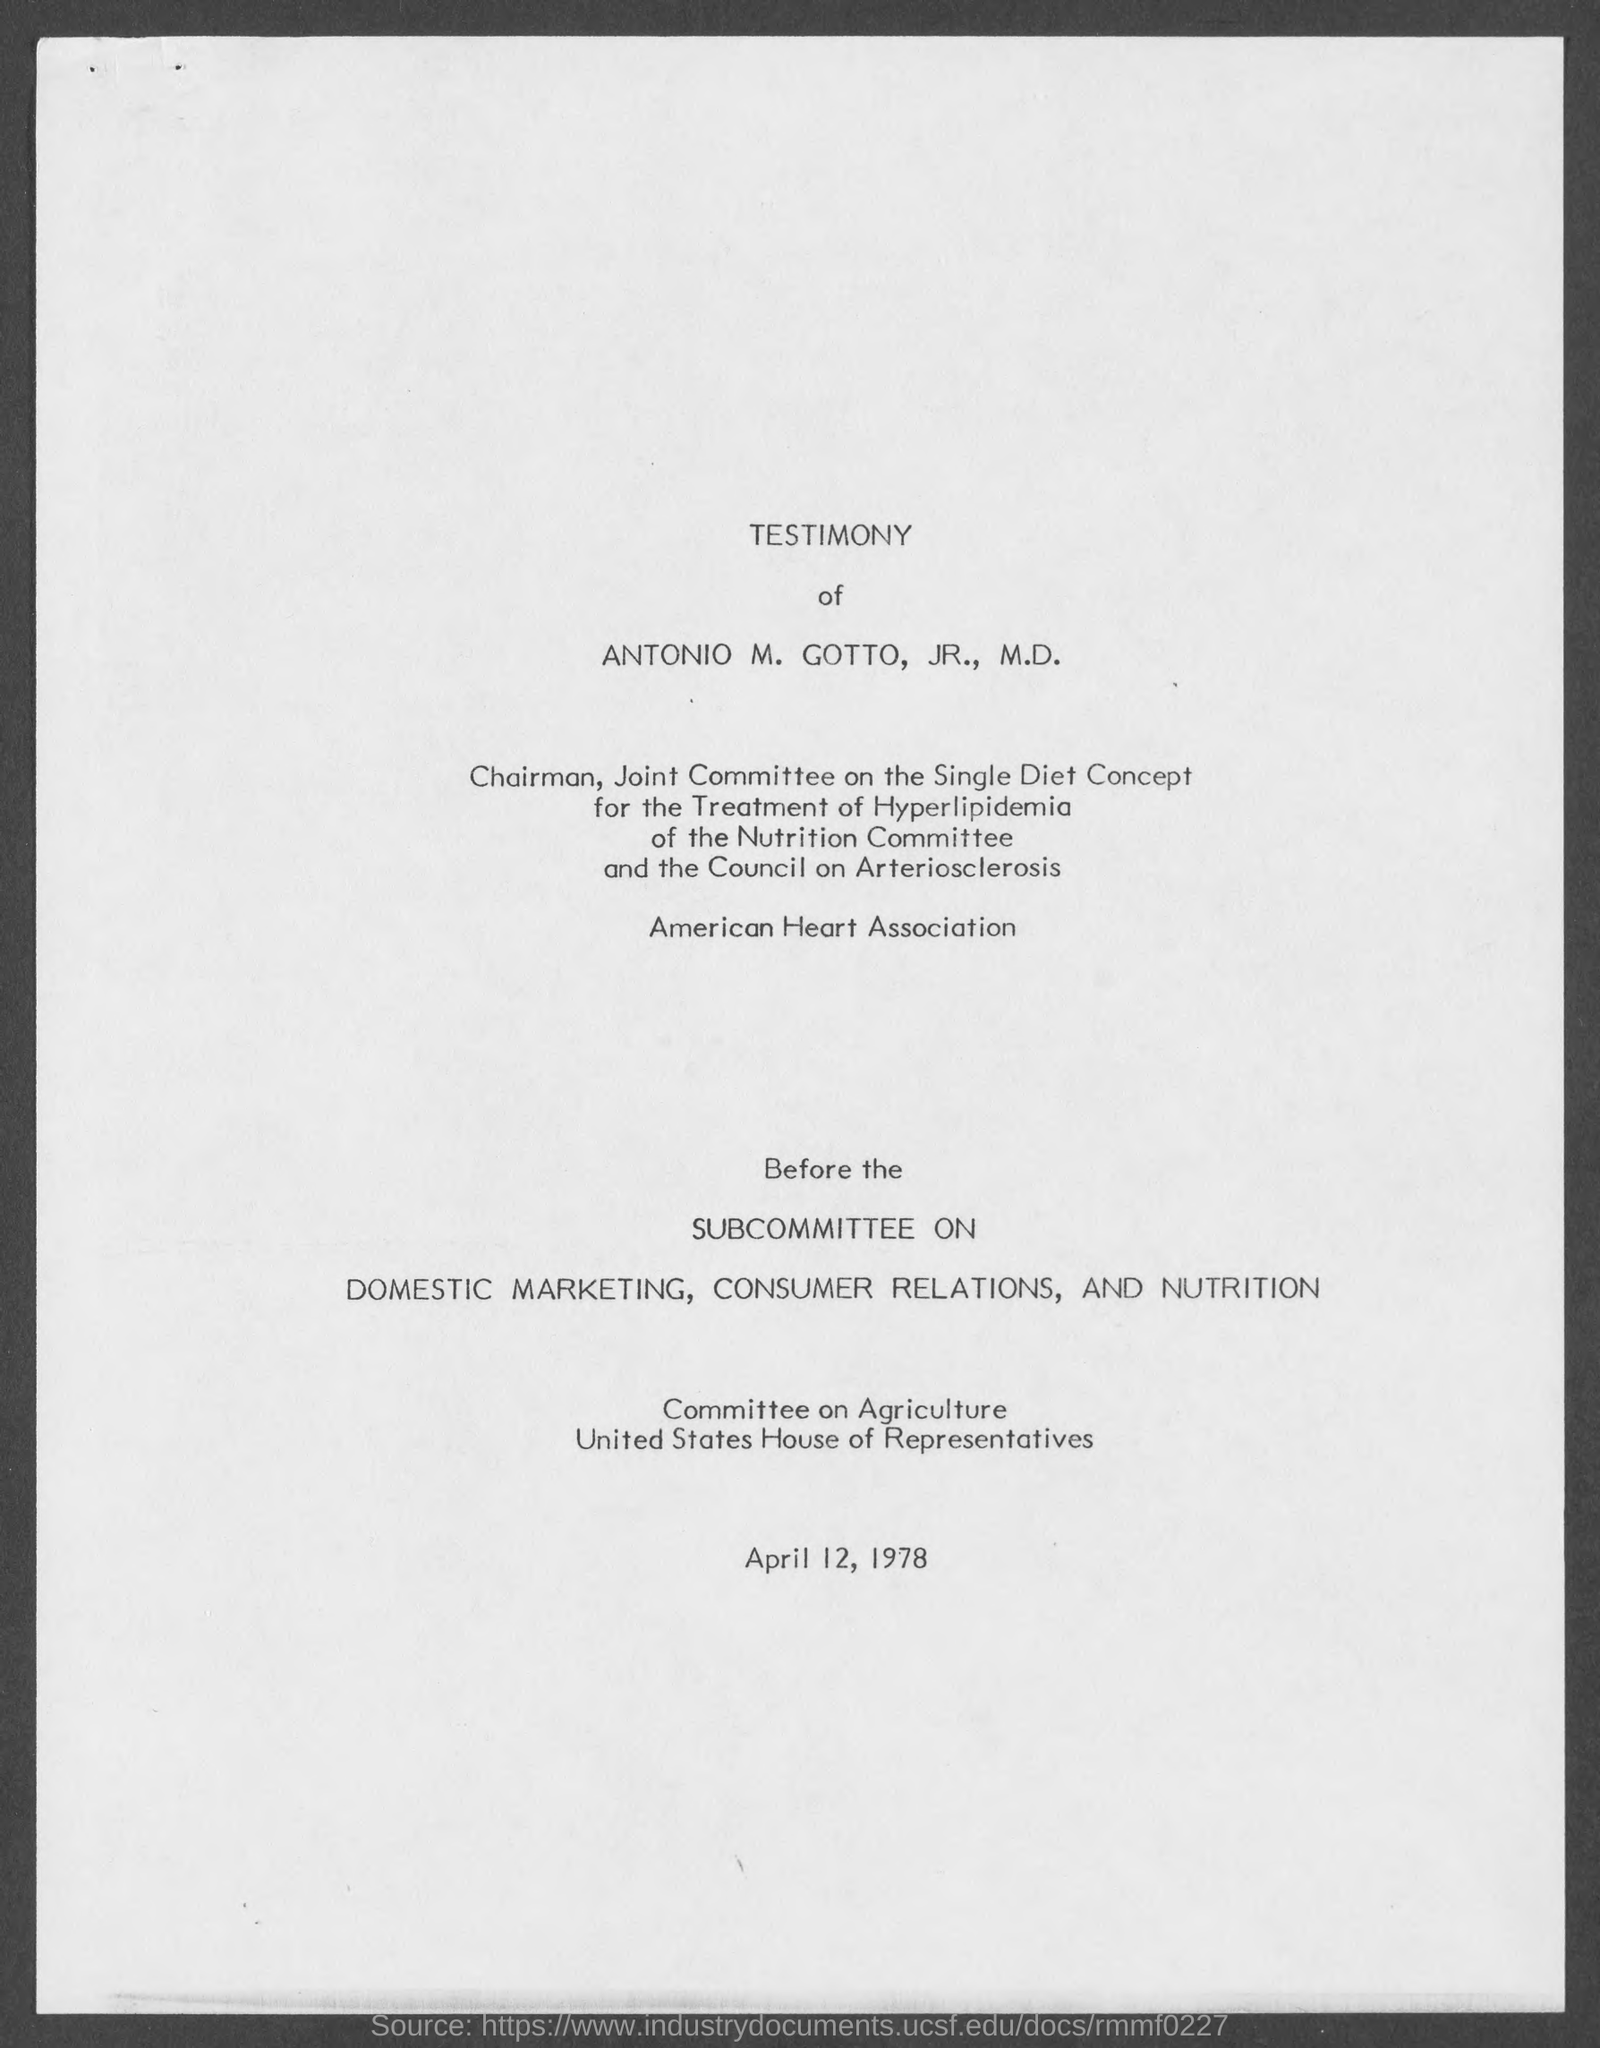Whose testimony is this?
Offer a terse response. Antonio M. Gotto, Jr. What is the date mentioned at bottom of the page?
Provide a succinct answer. April 12, 1978. 